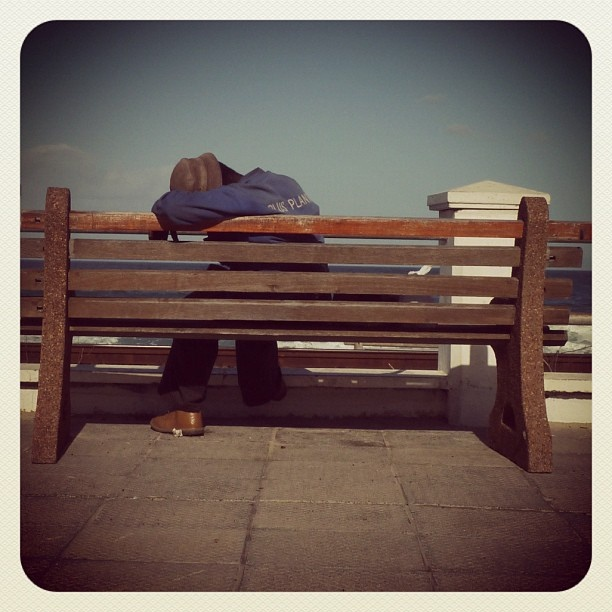Describe the objects in this image and their specific colors. I can see bench in ivory, maroon, brown, and black tones and people in ivory, gray, black, purple, and maroon tones in this image. 